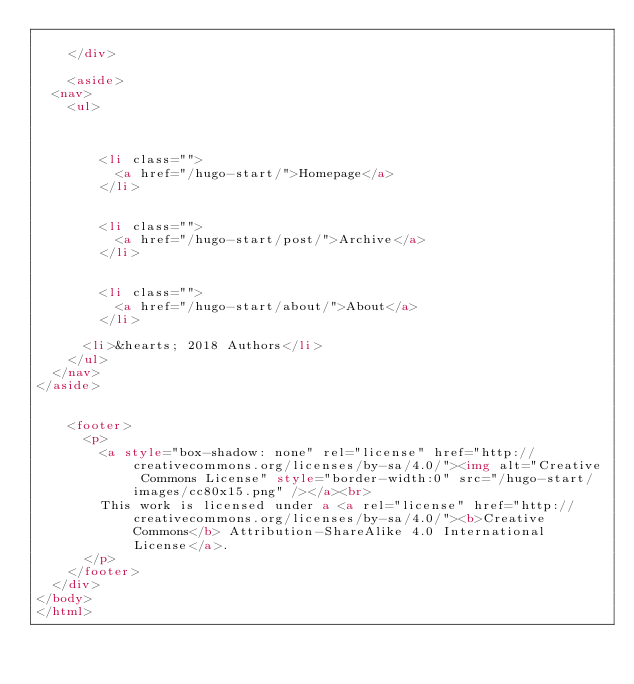Convert code to text. <code><loc_0><loc_0><loc_500><loc_500><_HTML_>
    </div>

    <aside>
  <nav>
    <ul>
      
      
        
        <li class="">
          <a href="/hugo-start/">Homepage</a>
        </li>
      
        
        <li class="">
          <a href="/hugo-start/post/">Archive</a>
        </li>
      
        
        <li class="">
          <a href="/hugo-start/about/">About</a>
        </li>
      
      <li>&hearts; 2018 Authors</li>
    </ul>
  </nav>
</aside>


    <footer>
      <p>
        <a style="box-shadow: none" rel="license" href="http://creativecommons.org/licenses/by-sa/4.0/"><img alt="Creative Commons License" style="border-width:0" src="/hugo-start/images/cc80x15.png" /></a><br>
        This work is licensed under a <a rel="license" href="http://creativecommons.org/licenses/by-sa/4.0/"><b>Creative Commons</b> Attribution-ShareAlike 4.0 International License</a>.
      </p>
    </footer>
  </div>
</body>
</html>
</code> 